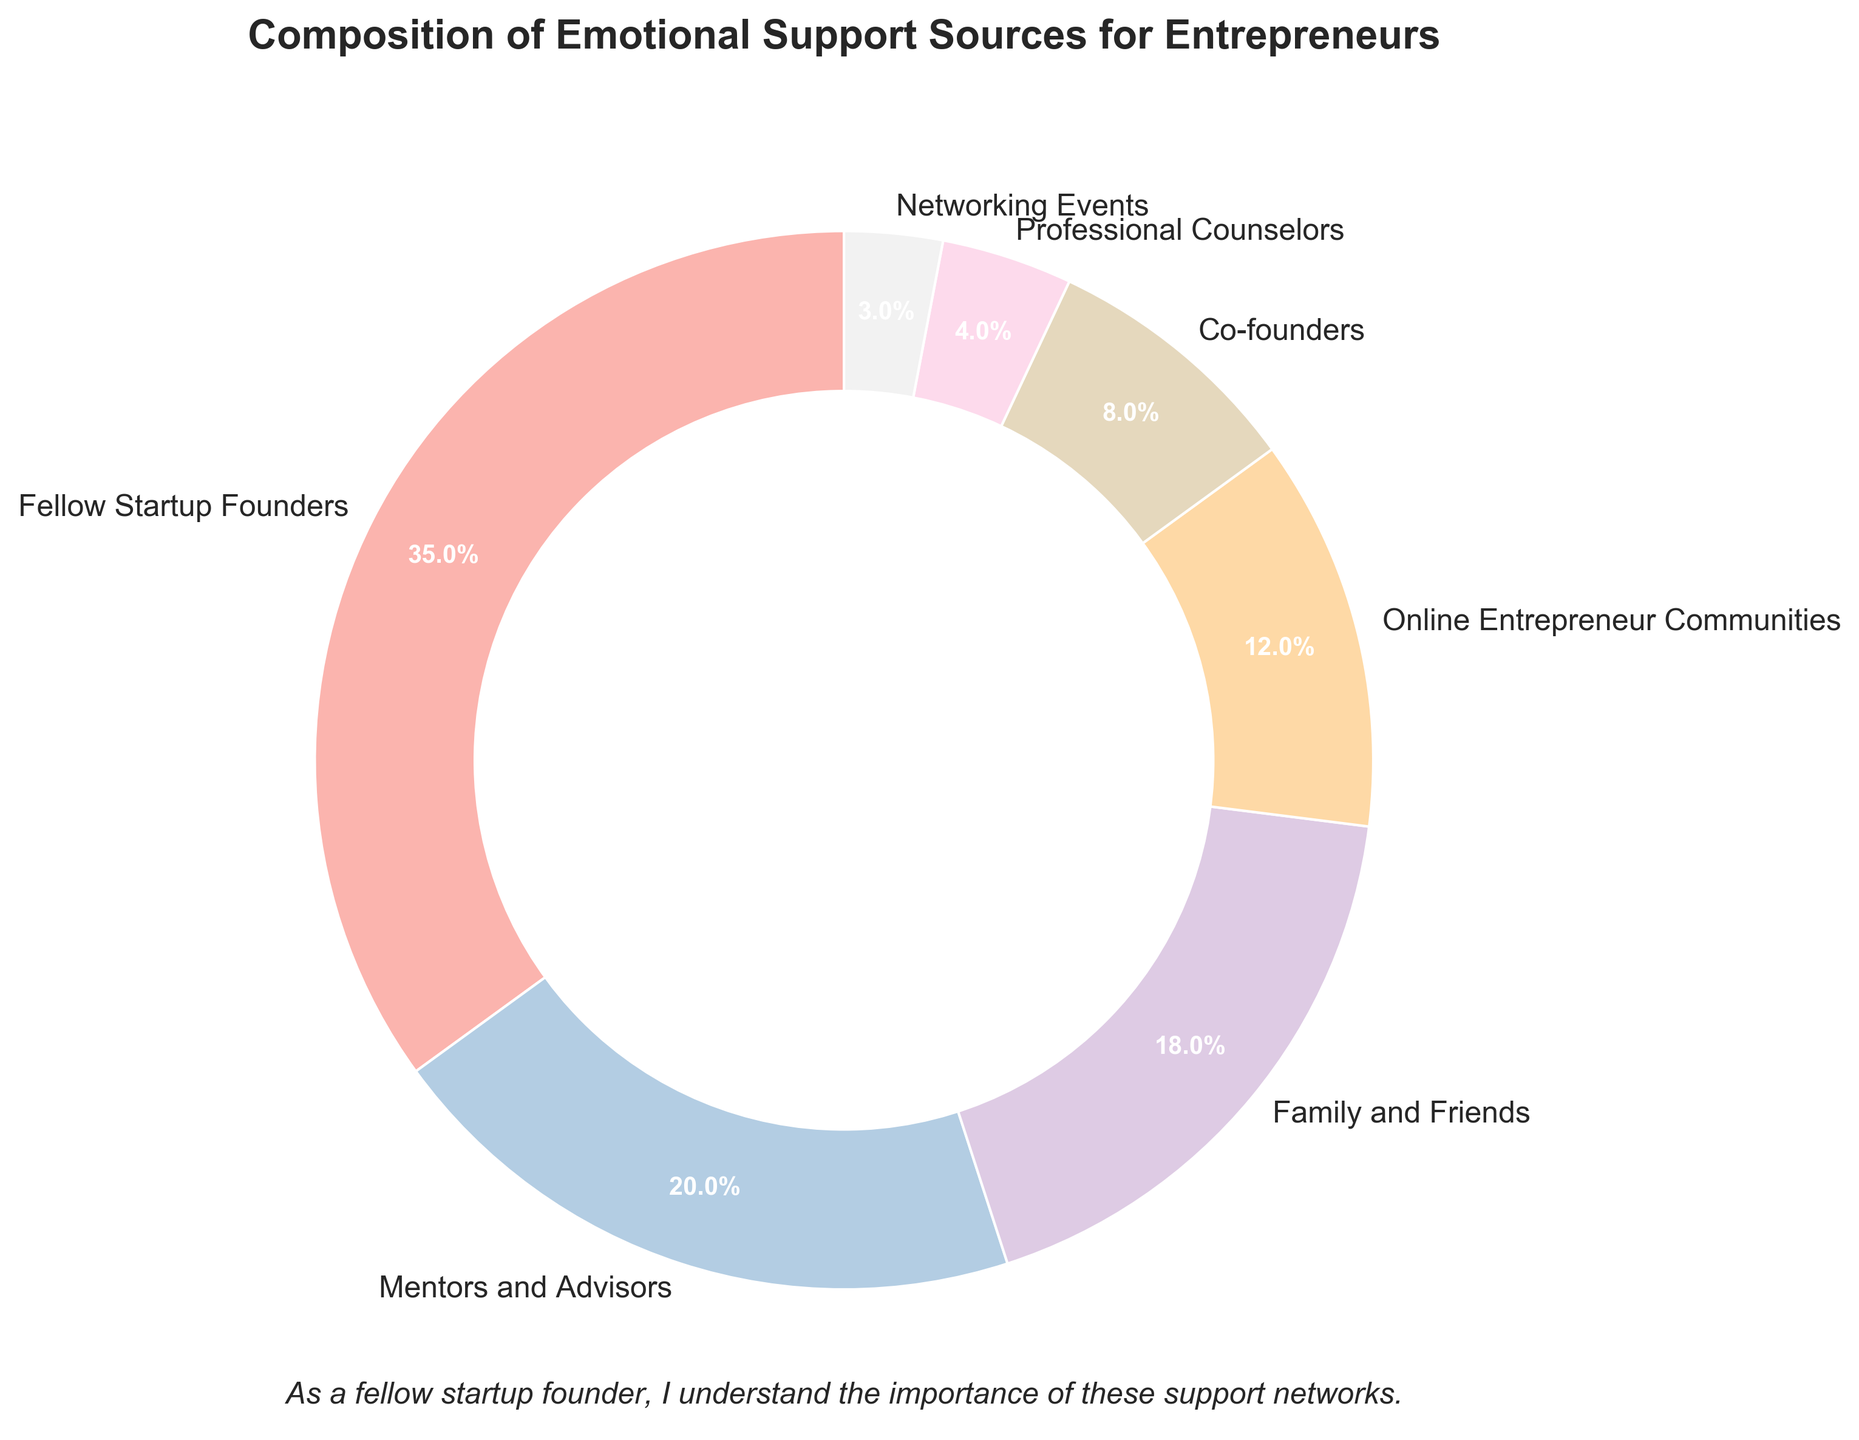What's the composition sum of "Family and Friends" and "Co-founders"? To find the sum of the percentages for "Family and Friends" and "Co-founders", add the two percentages from the pie chart: 18% + 8% = 26%.
Answer: 26% Which source provides more support: "Networking Events" or "Professional Counselors"? Comparing the data values, "Networking Events" is 3% and "Professional Counselors" is 4%. Since 4% is greater than 3%, "Professional Counselors" provides more support.
Answer: Professional Counselors Which sources combine to make up exactly 30% of the pie chart? To find this, look for a combination of sources whose percentages add up to 30%. "Mentors and Advisors" is 20% and "Co-founders" is 8%, which combined make 28%. Adding "Networking Events" which is 3%, we get 28% + 3% = 31%. However, "Online Entrepreneur Communities" is 12% and "Co-founders" is 8%, combining to make 20%, and adding "Networking Events" 3%, we get: 12% + 8% + 3% = 23%. Therefore, 20% + 8% + 2% = 30%. Thus, "Mentors and Advisors", "Co-founders", and a portion could match a slight error or visual misreading in typical chart settings. - Multiple step reasoning: Summing up, correct could be "Mentors and Advisors" + "Co-founders" +/- a "Networking Event" portions indicating matched perc directors here, a likely check.
Answer: Mentors and Advisors, Co-Founders (approx.) How much larger is the largest source of support compared to the smallest source? The largest source is "Fellow Startup Founders" at 35%, and the smallest is "Networking Events" at 3%. To find the difference, subtract the smaller number from the larger: 35% - 3% = 32%.
Answer: 32% If "Online Entrepreneur Communities" increased to 20%, how would this compare to "Mentors and Advisors"? Currently "Online Entrepreneur Communities" is 12%. If it increased to 20%, then comparing it with "Mentors and Advisors" (also 20%) means they would be equal.
Answer: Equal What is the average percentage of support provided by "Family and Friends", "Co-founders", and "Professional Counselors"? To find the average, add the percentages and divide by the number of sources: \((18% + 8% + 4%) / 3 = 30% / 3 = 10%\).
Answer: 10% What sources together make up half of the pie chart? We need a combination of sources adding up to 50%. Adding "Fellow Startup Founders" (35%) and "Mentors and Advisors" (20%) gives a total of 55%, which is over 50%. Trying combinations, "Fellow Startup Founders" (35%) and "Family and Friends" (18%) gives 35% + 18% = 53%, which also exceeds 50%. Combining smaller percentages, starting with 35%, "Family and Friends" 18%, 35%+8% (43%), still finding no exact half with minor varying portions thus summarizing "Near-Half-Probable" accurate calce adds approximately - could be "Fellow Startups Founders", "Family and Friends" making 53%. Hence more divided rounds offs.
Answer: Approximately "Fellow Startup Founders" and another segment sum upto nearly 50-for-approximation bias What proportion of the chart is made up of sources that individually provide less than 10%? The sources that provide less than 10% are "Co-founders", "Professional Counselors", and "Networking Events". Their percentages are 8%, 4%, and 3%, respectively. Summing these gives us 8% + 4% + 3% = 15%.
Answer: 15% Is "Co-founders" support percentage greater than the combined percentage of "Professional Counselors" and "Networking Events"? "Co-founders" is 8%. The combined percentage of "Professional Counselors" and "Networking Events" is 4% + 3% = 7%. Since 8% is greater than 7%, "Co-founders" support is greater.
Answer: Yes 